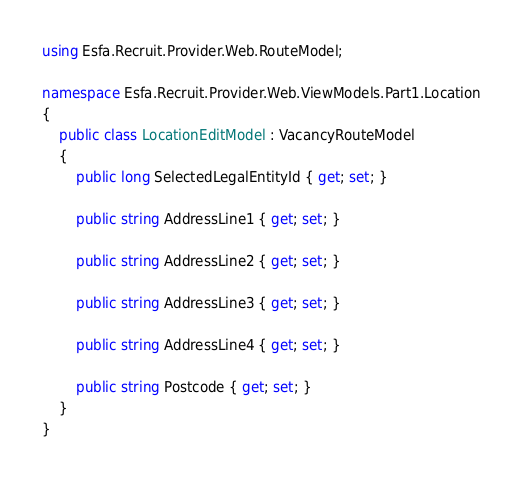<code> <loc_0><loc_0><loc_500><loc_500><_C#_>using Esfa.Recruit.Provider.Web.RouteModel;

namespace Esfa.Recruit.Provider.Web.ViewModels.Part1.Location
{
    public class LocationEditModel : VacancyRouteModel
    {
        public long SelectedLegalEntityId { get; set; }

        public string AddressLine1 { get; set; }

        public string AddressLine2 { get; set; }

        public string AddressLine3 { get; set; }

        public string AddressLine4 { get; set; }

        public string Postcode { get; set; }
    }
}</code> 